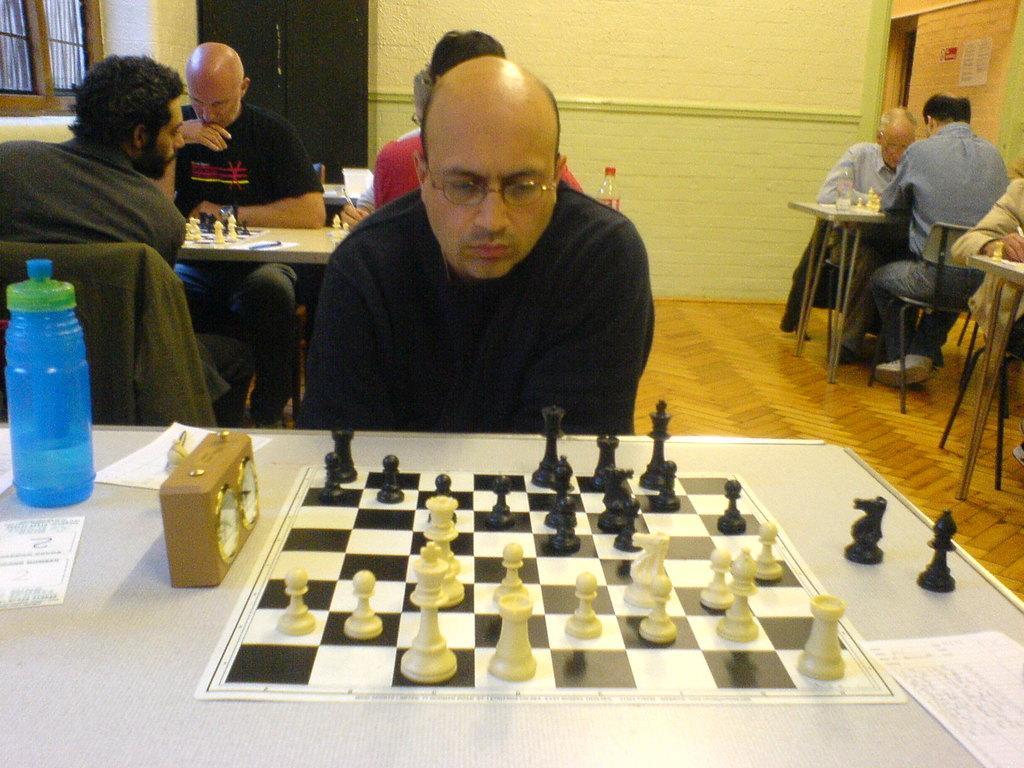How would you summarize this image in a sentence or two? In this image, there are some persons sitting in a chair and playing a chess. These persons are sitting in front of these tables. These tables contains bottles and chess boards. 